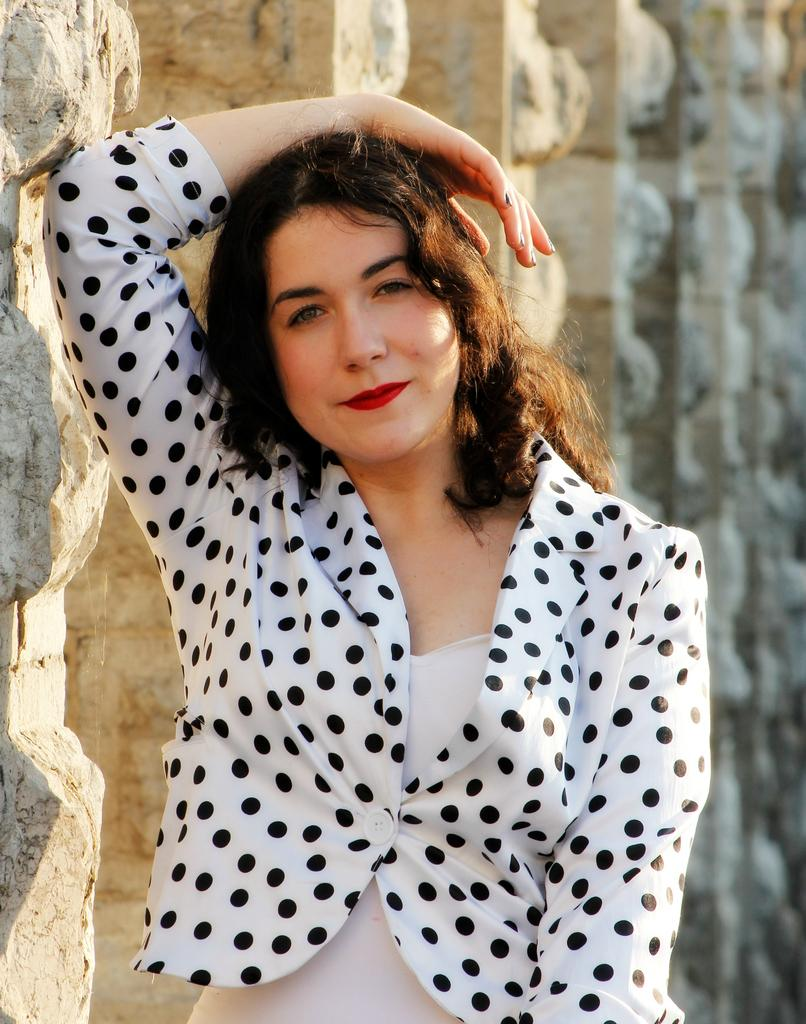Who or what is the main subject in the image? There is a person in the image. Can you describe the person's position in relation to the image? The person is in front. What can be seen behind the person? There are pillars behind the person. What type of rod is the person holding in the image? There is no rod present in the image. Can you describe the jellyfish swimming near the person in the image? There are no jellyfish present in the image. 